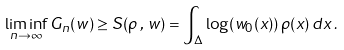Convert formula to latex. <formula><loc_0><loc_0><loc_500><loc_500>\liminf _ { n \to \infty } G _ { n } ( w ) \geq S ( \rho \, , \, w ) = \int _ { \Delta } \log ( w _ { 0 } ( x ) ) \, \rho ( x ) \, d x \, .</formula> 